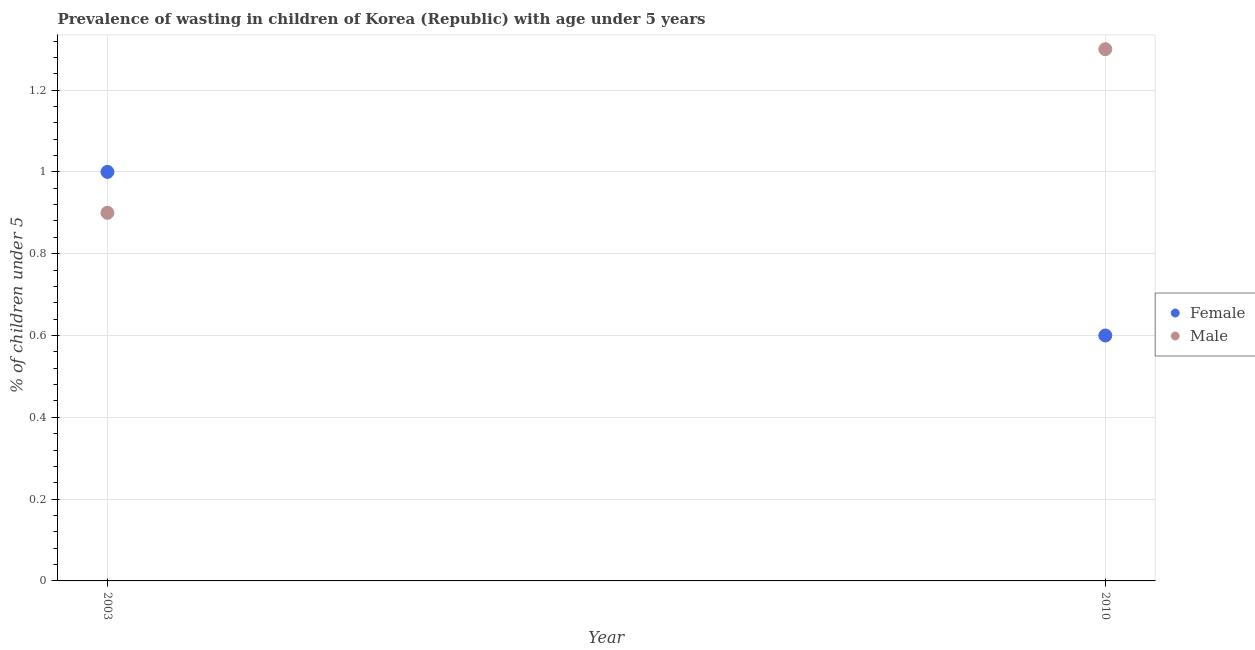How many different coloured dotlines are there?
Your response must be concise. 2. What is the percentage of undernourished male children in 2003?
Your answer should be compact. 0.9. Across all years, what is the minimum percentage of undernourished female children?
Give a very brief answer. 0.6. In which year was the percentage of undernourished male children maximum?
Offer a terse response. 2010. In which year was the percentage of undernourished female children minimum?
Provide a succinct answer. 2010. What is the total percentage of undernourished female children in the graph?
Your response must be concise. 1.6. What is the difference between the percentage of undernourished female children in 2003 and that in 2010?
Provide a short and direct response. 0.4. What is the difference between the percentage of undernourished female children in 2003 and the percentage of undernourished male children in 2010?
Give a very brief answer. -0.3. What is the average percentage of undernourished female children per year?
Provide a succinct answer. 0.8. In the year 2010, what is the difference between the percentage of undernourished female children and percentage of undernourished male children?
Your response must be concise. -0.7. In how many years, is the percentage of undernourished female children greater than 0.44 %?
Your response must be concise. 2. What is the ratio of the percentage of undernourished male children in 2003 to that in 2010?
Give a very brief answer. 0.69. Where does the legend appear in the graph?
Your response must be concise. Center right. How many legend labels are there?
Offer a very short reply. 2. What is the title of the graph?
Offer a very short reply. Prevalence of wasting in children of Korea (Republic) with age under 5 years. Does "Highest 20% of population" appear as one of the legend labels in the graph?
Your answer should be compact. No. What is the label or title of the X-axis?
Ensure brevity in your answer.  Year. What is the label or title of the Y-axis?
Make the answer very short.  % of children under 5. What is the  % of children under 5 in Male in 2003?
Provide a short and direct response. 0.9. What is the  % of children under 5 in Female in 2010?
Your answer should be compact. 0.6. What is the  % of children under 5 of Male in 2010?
Offer a terse response. 1.3. Across all years, what is the maximum  % of children under 5 of Male?
Provide a short and direct response. 1.3. Across all years, what is the minimum  % of children under 5 of Female?
Provide a succinct answer. 0.6. Across all years, what is the minimum  % of children under 5 in Male?
Your answer should be very brief. 0.9. What is the total  % of children under 5 of Female in the graph?
Offer a very short reply. 1.6. What is the total  % of children under 5 of Male in the graph?
Offer a very short reply. 2.2. What is the difference between the  % of children under 5 of Female in 2003 and that in 2010?
Provide a succinct answer. 0.4. What is the average  % of children under 5 in Female per year?
Ensure brevity in your answer.  0.8. What is the ratio of the  % of children under 5 in Male in 2003 to that in 2010?
Keep it short and to the point. 0.69. 